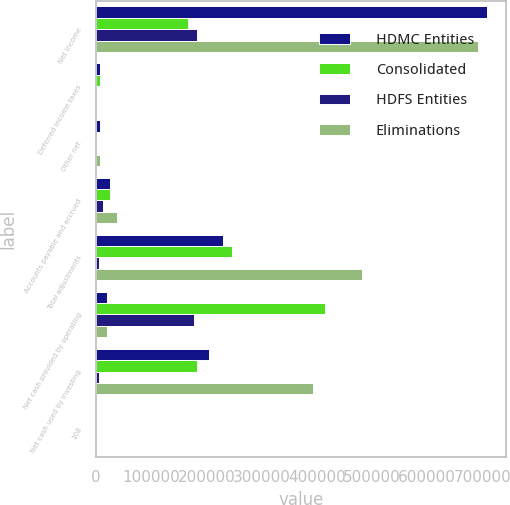Convert chart. <chart><loc_0><loc_0><loc_500><loc_500><stacked_bar_chart><ecel><fcel>Net income<fcel>Deferred income taxes<fcel>Other net<fcel>Accounts payable and accrued<fcel>Total adjustments<fcel>Net cash provided by operating<fcel>Net cash used by investing<fcel>108<nl><fcel>HDMC Entities<fcel>707614<fcel>7772<fcel>7041<fcel>26005<fcel>230410<fcel>18911<fcel>204891<fcel>108<nl><fcel>Consolidated<fcel>167445<fcel>7705<fcel>239<fcel>25027<fcel>246443<fcel>413888<fcel>182413<fcel>108<nl><fcel>HDFS Entities<fcel>182895<fcel>232<fcel>105<fcel>12795<fcel>5322<fcel>177573<fcel>5427<fcel>108<nl><fcel>Eliminations<fcel>692164<fcel>165<fcel>6907<fcel>38237<fcel>482175<fcel>18911<fcel>392731<fcel>108<nl></chart> 